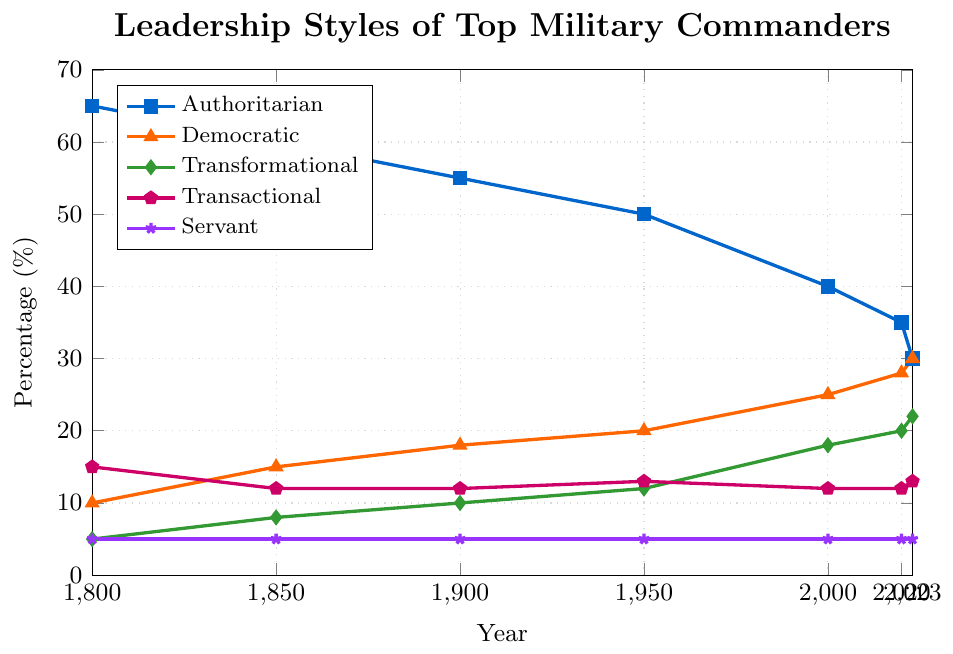What is the trend in the frequency of Authoritarian leadership from 1800 to 2023? The line representing Authoritarian leadership shows a general downward trend from 1800 (65%) to 2023 (30%), indicating a decrease in its frequency over time.
Answer: Decreasing In which year did Transformational leadership surpass 15% for the first time? To find this, look at the Transformational line on the plot. It surpasses 15% for the first time between 1950 (12%) and 2000 (18%). Thus, the first year it surpasses 15% is 2000.
Answer: 2000 Compare the percentage of Democratic leadership in 1900 and 2020. Which year has a higher percentage and by how much? The Democratic leadership in 1900 is 18%, and in 2020 it is 28%. To find the difference, subtract 18% from 28%, resulting in 10%.
Answer: 2020, 10% What is the combined percentage of Transactional and Servant leadership in 2023? The Transactional leadership in 2023 is 13%, and Servant leadership is 5%. Adding these together gives 13% + 5% = 18%.
Answer: 18% How does the percentage of Transformational leadership in 2023 compare to Authoritarian leadership in 1950? The Transformational leadership in 2023 is 22%, and the Authoritarian leadership in 1950 is 50%. Transformational in 2023 is less than Authoritarian in 1950 by 50% - 22% = 28%.
Answer: Authoritarian leadership in 1950 is higher by 28% What is the total percentage change for Democratic leadership from 1800 to 2023? The percentage of Democratic leadership in 1800 is 10%, and in 2023 it is 30%. The total percentage change is calculated as 30% - 10% = 20%.
Answer: 20% What leadership style remained constant in its frequency from 1800 to 2023? By visually checking all lines, the Servant leadership style remained constant at 5% throughout the years from 1800 to 2023.
Answer: Servant In which decade did the Authoritarian leadership experience the most significant drop, and what was the percentage decrease? By examining the plot, the most notable drop in the Authoritarian leadership line occurs between 2000 (40%) and 2020 (35%). The percentage decrease is 40% - 35% = 5%.
Answer: Between 2000 and 2020, 5% What is the difference between the highest and lowest recorded percentages for Transformational leadership? The highest recorded percentage for Transformational leadership is 22% in 2023, and the lowest is 5% in 1800. The difference is 22% - 5% = 17%.
Answer: 17% 